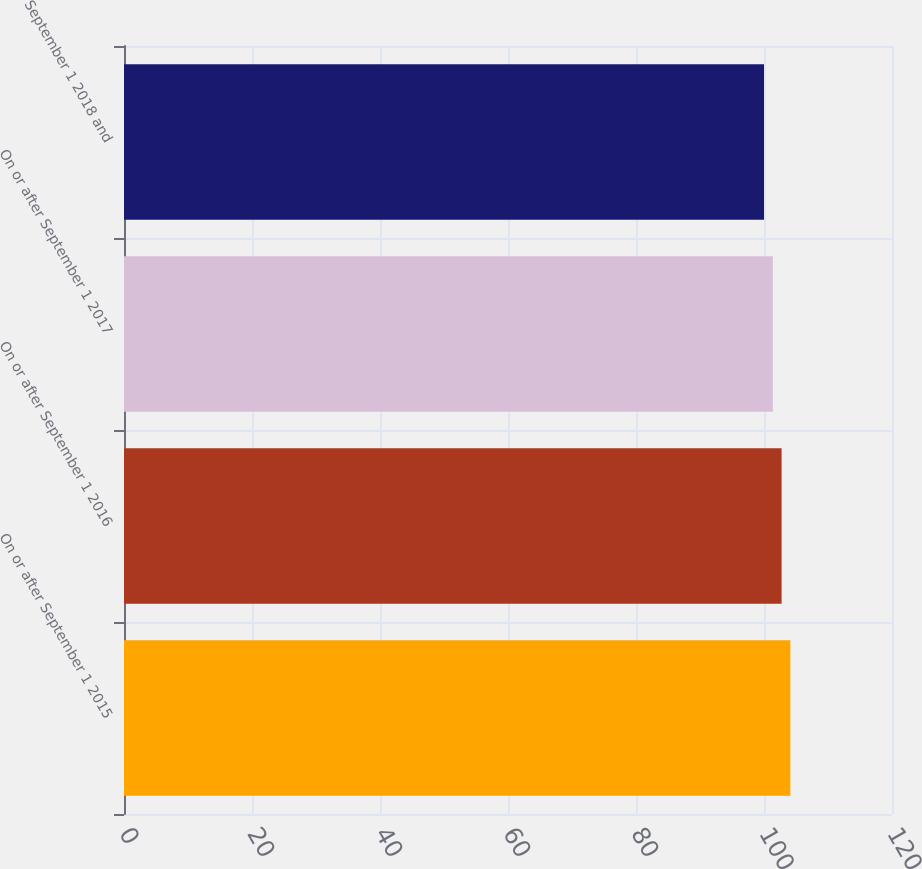<chart> <loc_0><loc_0><loc_500><loc_500><bar_chart><fcel>On or after September 1 2015<fcel>On or after September 1 2016<fcel>On or after September 1 2017<fcel>September 1 2018 and<nl><fcel>104.12<fcel>102.75<fcel>101.38<fcel>100<nl></chart> 